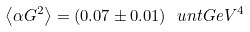<formula> <loc_0><loc_0><loc_500><loc_500>\left \langle \alpha G ^ { 2 } \right \rangle = ( 0 . 0 7 \pm 0 . 0 1 ) \ u n t { G e V ^ { 4 } }</formula> 